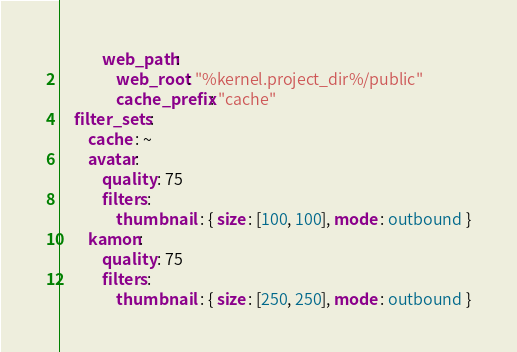<code> <loc_0><loc_0><loc_500><loc_500><_YAML_>            web_path:
                web_root: "%kernel.project_dir%/public"
                cache_prefix: "cache"
    filter_sets :
        cache : ~
        avatar:
            quality : 75
            filters :
                thumbnail  : { size : [100, 100], mode : outbound }
        kamon:
            quality : 75
            filters :
                thumbnail  : { size : [250, 250], mode : outbound }</code> 